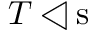<formula> <loc_0><loc_0><loc_500><loc_500>T \triangleleft { s }</formula> 